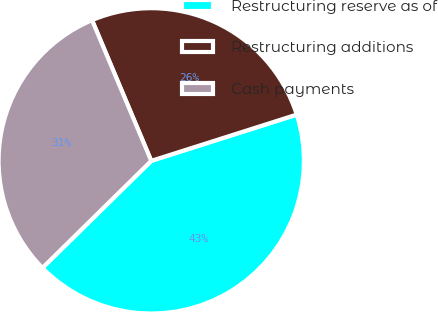Convert chart. <chart><loc_0><loc_0><loc_500><loc_500><pie_chart><fcel>Restructuring reserve as of<fcel>Restructuring additions<fcel>Cash payments<nl><fcel>42.53%<fcel>26.44%<fcel>31.03%<nl></chart> 